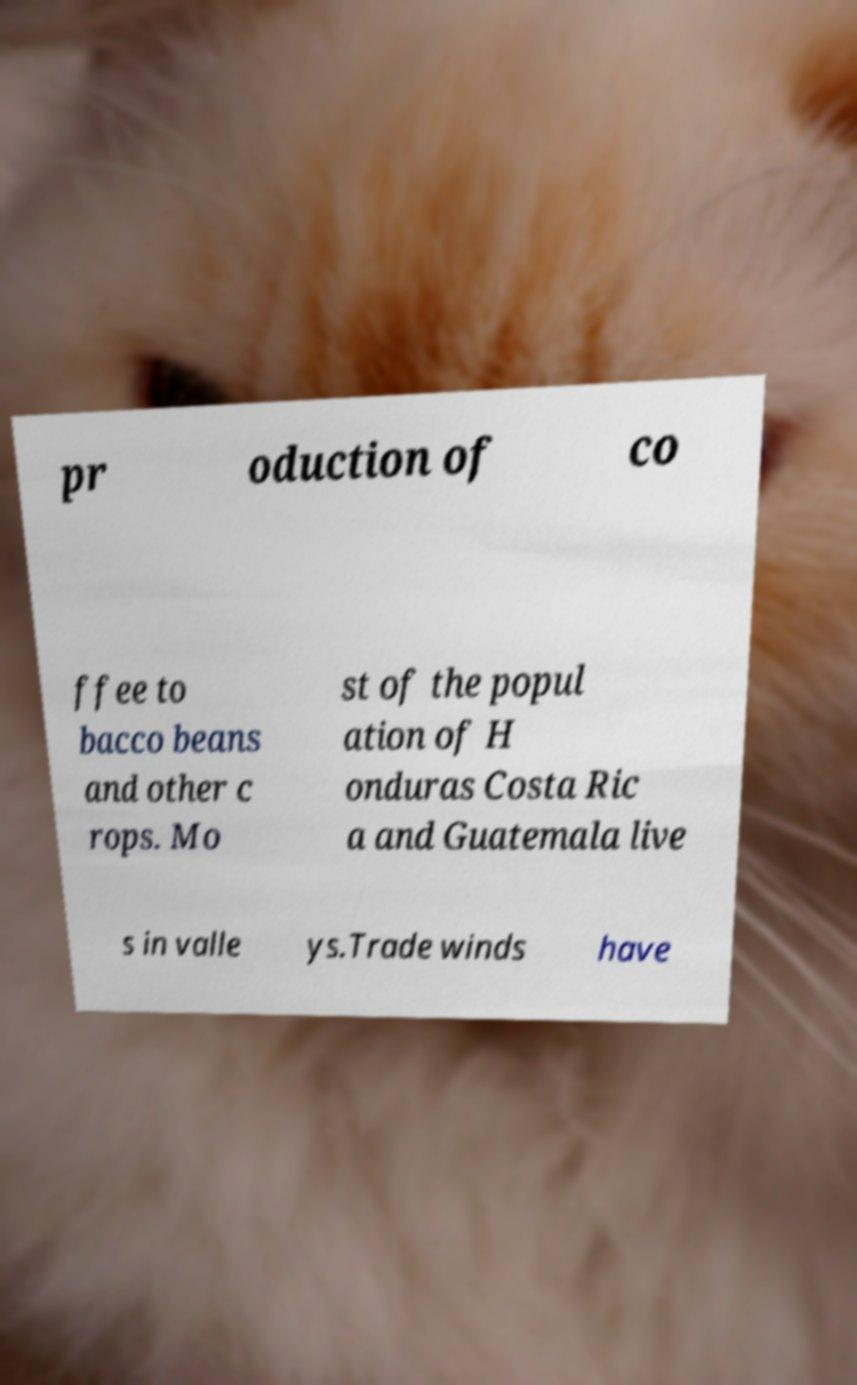Can you accurately transcribe the text from the provided image for me? pr oduction of co ffee to bacco beans and other c rops. Mo st of the popul ation of H onduras Costa Ric a and Guatemala live s in valle ys.Trade winds have 